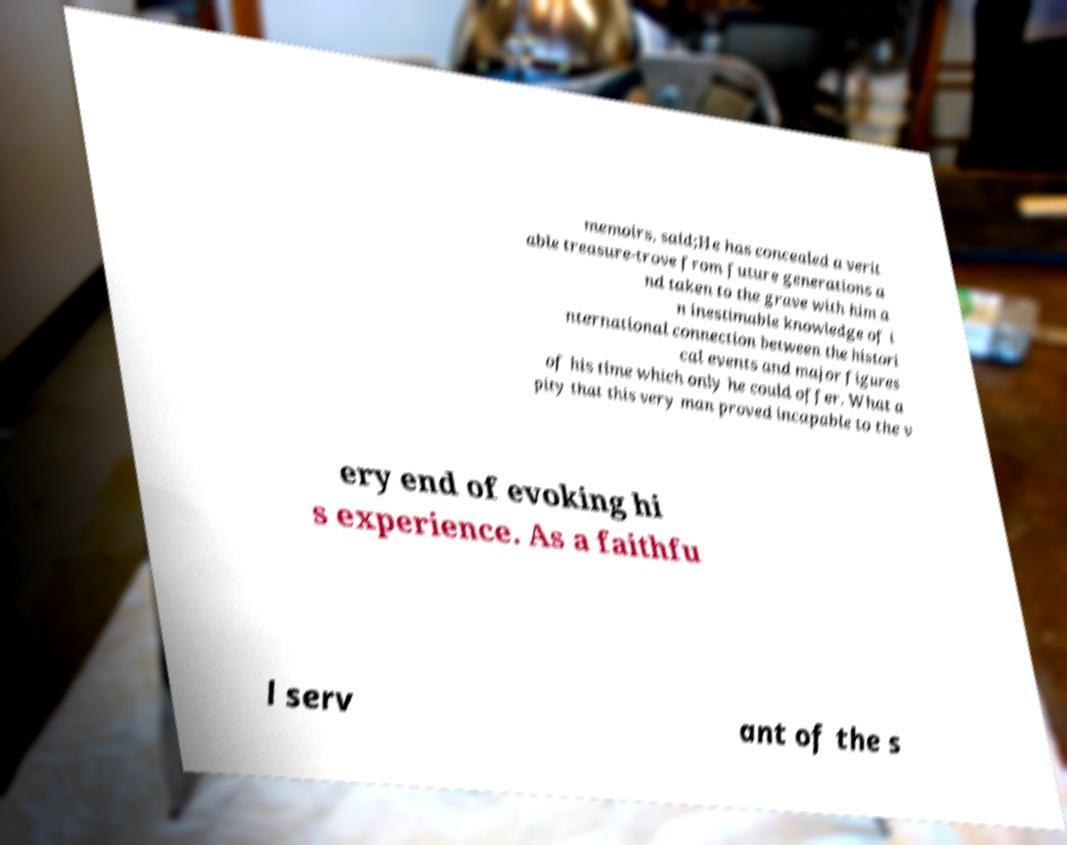Could you extract and type out the text from this image? memoirs, said;He has concealed a verit able treasure-trove from future generations a nd taken to the grave with him a n inestimable knowledge of i nternational connection between the histori cal events and major figures of his time which only he could offer. What a pity that this very man proved incapable to the v ery end of evoking hi s experience. As a faithfu l serv ant of the s 